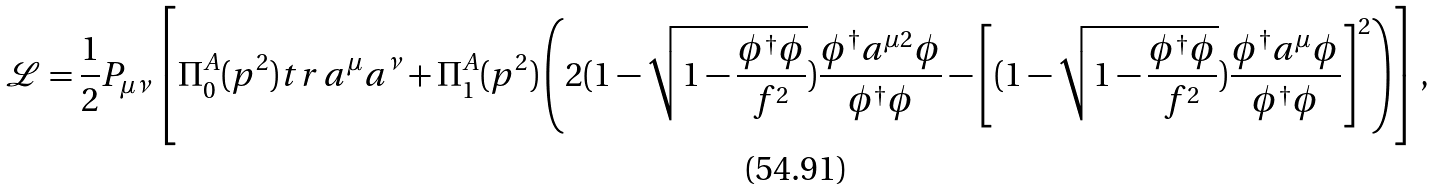Convert formula to latex. <formula><loc_0><loc_0><loc_500><loc_500>\mathcal { L } = \frac { 1 } { 2 } P _ { \mu \nu } \left [ \Pi _ { 0 } ^ { A } ( p ^ { 2 } ) t r \, a ^ { \mu } a ^ { \nu } + \Pi _ { 1 } ^ { A } ( p ^ { 2 } ) \left ( 2 ( 1 - \sqrt { 1 - \frac { \phi ^ { \dagger } \phi } { f ^ { 2 } } } ) \frac { \phi ^ { \dagger } a ^ { \mu 2 } \phi } { \phi ^ { \dagger } \phi } - \left [ ( 1 - \sqrt { 1 - \frac { \phi ^ { \dagger } \phi } { f ^ { 2 } } } ) \frac { \phi ^ { \dagger } a ^ { \mu } \phi } { \phi ^ { \dagger } \phi } \right ] ^ { 2 } \right ) \right ] ,</formula> 